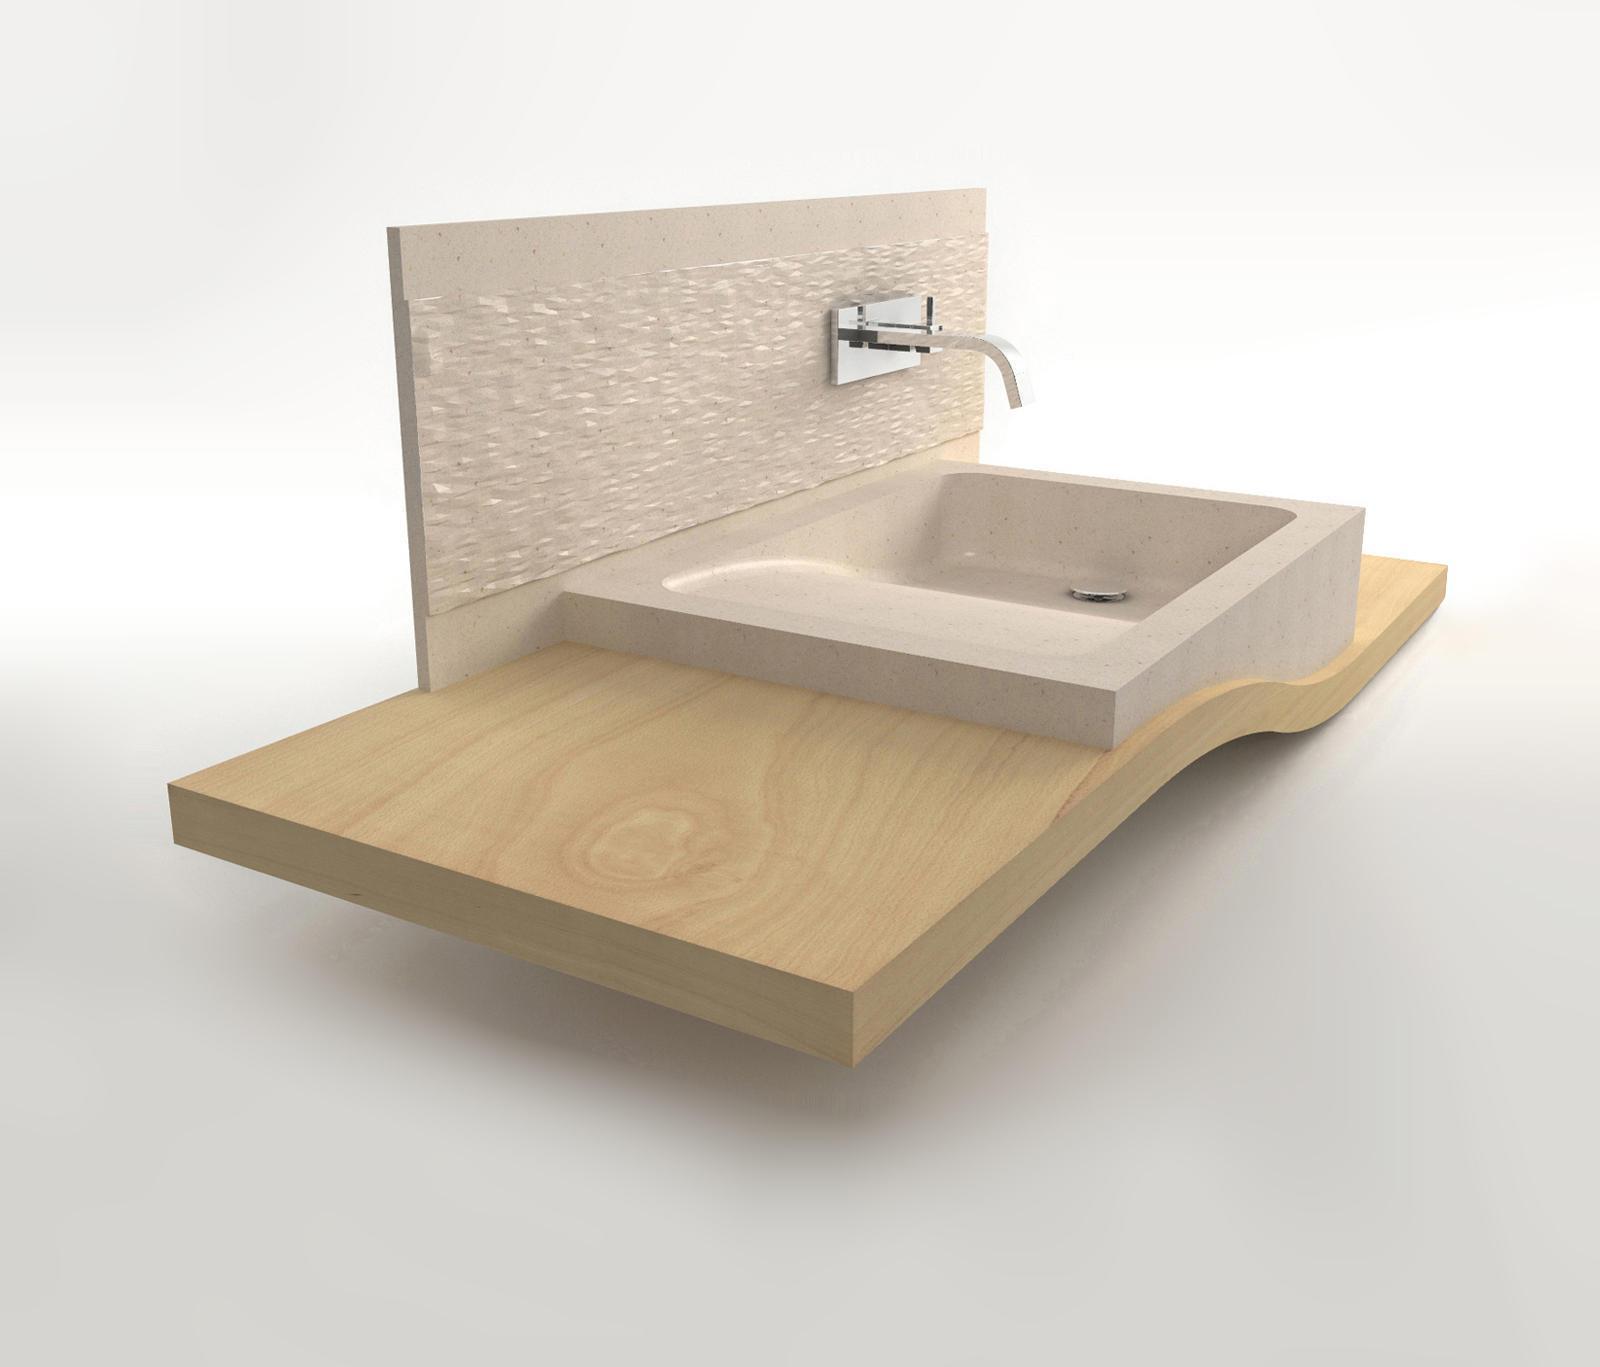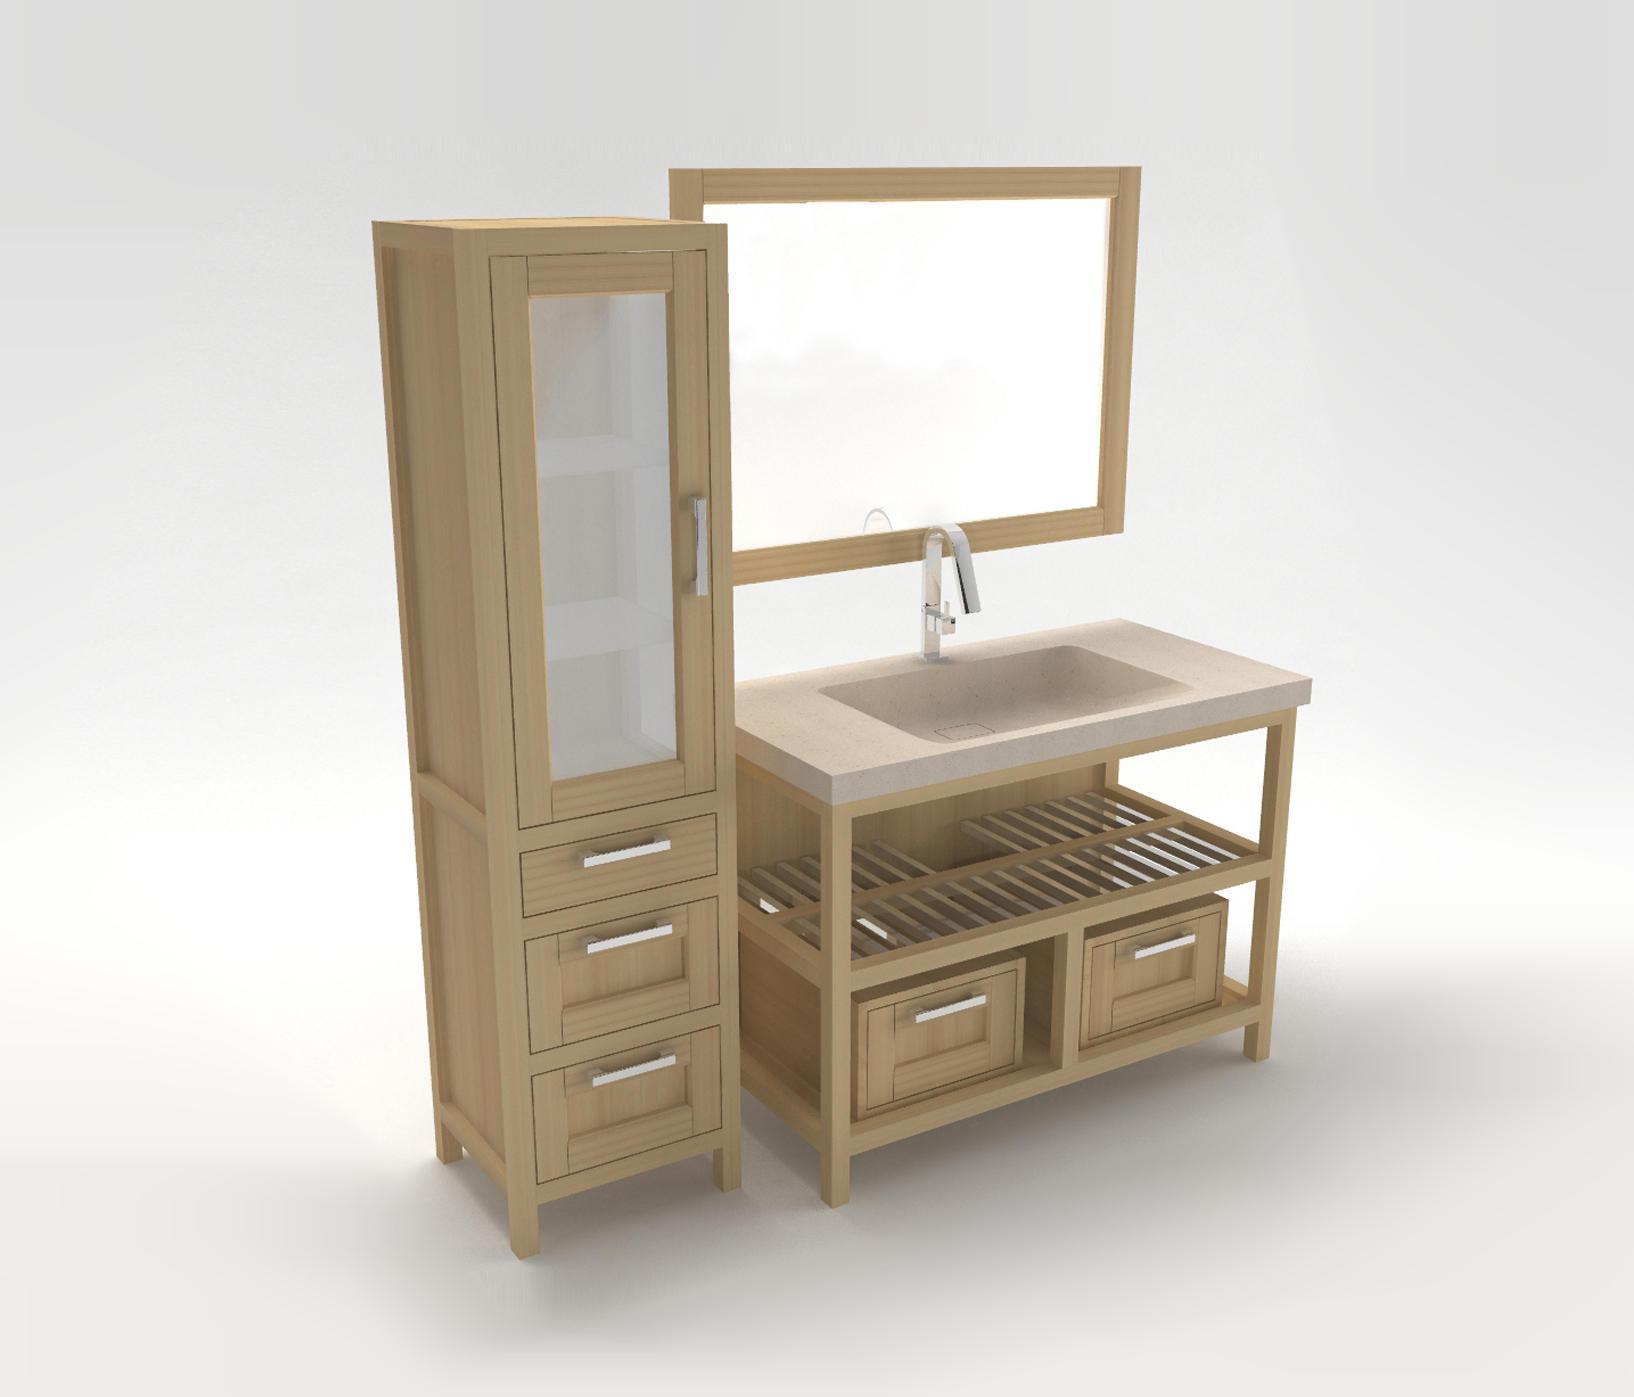The first image is the image on the left, the second image is the image on the right. Evaluate the accuracy of this statement regarding the images: "There are two sinks with faucets and bowls.". Is it true? Answer yes or no. Yes. 